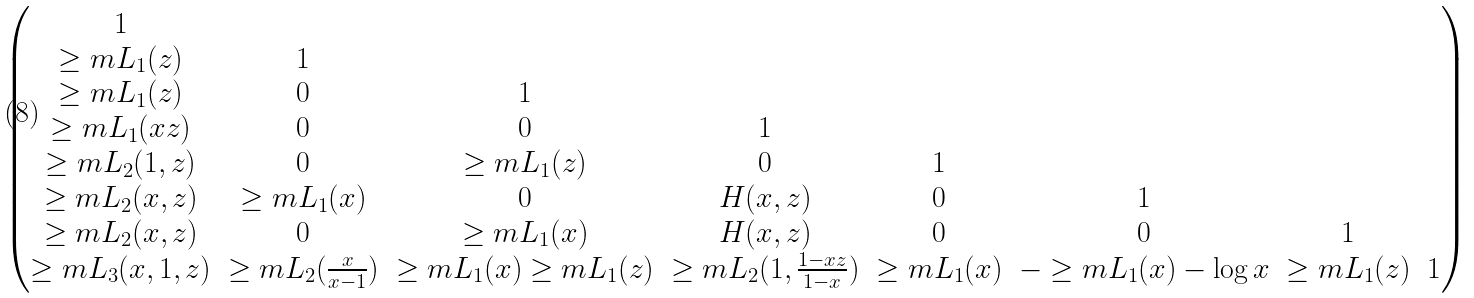<formula> <loc_0><loc_0><loc_500><loc_500>\begin{pmatrix} 1 & \ & \ & \ & \ & \ & \ & \ \\ \geq m L _ { 1 } ( z ) & 1 & \ & \ & \ & \ & \ & \ \\ \geq m L _ { 1 } ( z ) & 0 & 1 & \ & \ & \ & \ & \ \\ \geq m L _ { 1 } ( x z ) & 0 & 0 & 1 & \ & \ & \ & \ \\ \geq m L _ { 2 } ( 1 , z ) & 0 & \geq m L _ { 1 } ( z ) & 0 & 1 & \ & \ & \ \\ \geq m L _ { 2 } ( x , z ) & \geq m L _ { 1 } ( x ) & 0 & H ( x , z ) & 0 & 1 & \ & \ \\ \geq m L _ { 2 } ( x , z ) & 0 & \geq m L _ { 1 } ( x ) & H ( x , z ) & 0 & 0 & 1 & \ \\ \geq m L _ { 3 } ( x , 1 , z ) & \geq m L _ { 2 } ( \frac { x } { x - 1 } ) & \geq m L _ { 1 } ( x ) \geq m L _ { 1 } ( z ) & \geq m L _ { 2 } ( 1 , \frac { 1 - x z } { 1 - x } ) & \geq m L _ { 1 } ( x ) & - \geq m L _ { 1 } ( x ) - \log x & \geq m L _ { 1 } ( z ) & 1 \end{pmatrix}</formula> 